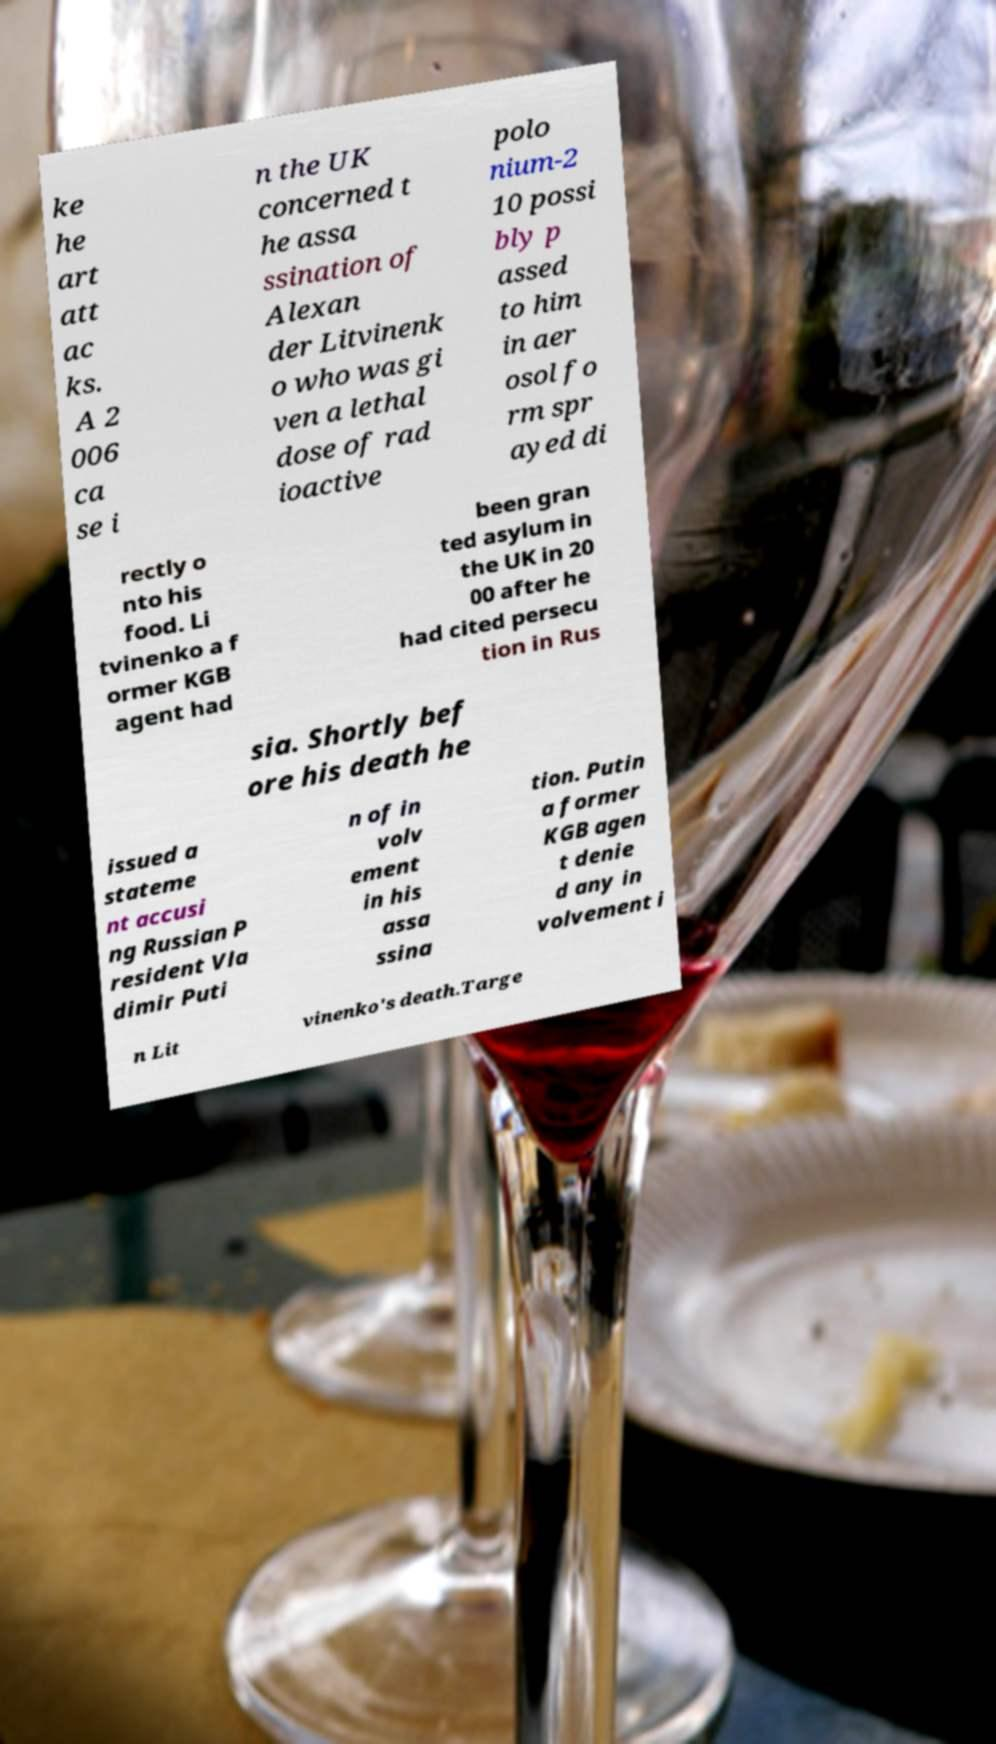Can you accurately transcribe the text from the provided image for me? ke he art att ac ks. A 2 006 ca se i n the UK concerned t he assa ssination of Alexan der Litvinenk o who was gi ven a lethal dose of rad ioactive polo nium-2 10 possi bly p assed to him in aer osol fo rm spr ayed di rectly o nto his food. Li tvinenko a f ormer KGB agent had been gran ted asylum in the UK in 20 00 after he had cited persecu tion in Rus sia. Shortly bef ore his death he issued a stateme nt accusi ng Russian P resident Vla dimir Puti n of in volv ement in his assa ssina tion. Putin a former KGB agen t denie d any in volvement i n Lit vinenko's death.Targe 